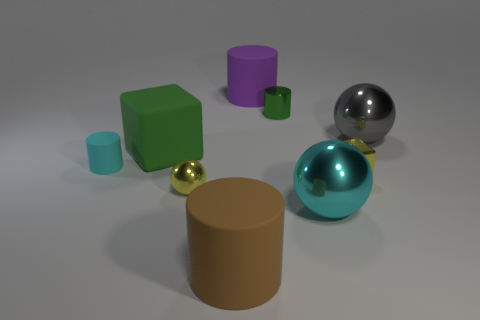Are there an equal number of objects to the right of the tiny cyan object and gray matte objects?
Provide a short and direct response. No. Is the size of the yellow thing that is on the right side of the cyan metallic thing the same as the green shiny cylinder?
Keep it short and to the point. Yes. What number of big things are there?
Give a very brief answer. 5. How many objects are both to the right of the purple matte object and in front of the green cylinder?
Provide a succinct answer. 3. Are there any tiny things that have the same material as the tiny green cylinder?
Your answer should be very brief. Yes. There is a cyan object that is on the right side of the tiny cylinder behind the small cyan cylinder; what is its material?
Your answer should be compact. Metal. Are there an equal number of rubber objects right of the green shiny object and large rubber things that are left of the brown thing?
Keep it short and to the point. No. Do the big purple object and the brown matte thing have the same shape?
Provide a succinct answer. Yes. There is a large thing that is to the left of the small shiny block and behind the green block; what material is it?
Offer a very short reply. Rubber. How many brown rubber objects are the same shape as the cyan metal thing?
Make the answer very short. 0. 